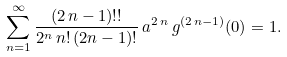Convert formula to latex. <formula><loc_0><loc_0><loc_500><loc_500>\sum _ { n = 1 } ^ { \infty } \frac { ( 2 \, n - 1 ) ! ! } { 2 ^ { n } \, n ! \, ( 2 n - 1 ) ! } \, a ^ { 2 \, n } \, g ^ { ( 2 \, n - 1 ) } ( 0 ) = 1 .</formula> 